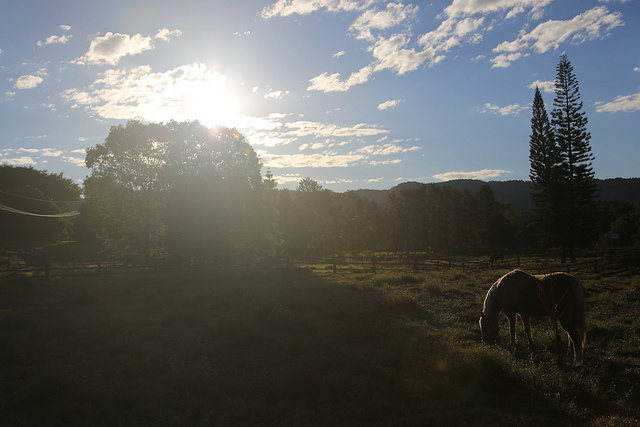What kind of animals can you see in the image? In the image, there's a single horse visible, grazing in the foreground. What is the horse doing? The horse seems to be leisurely grazing on the grass field, perhaps enjoying a peaceful morning meal. 